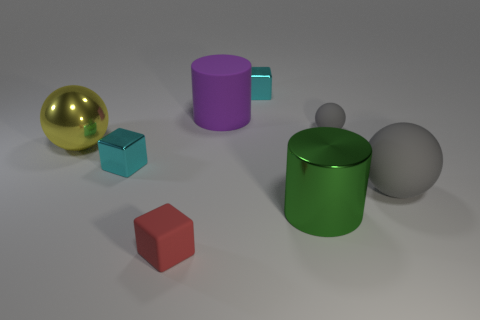Subtract all yellow balls. How many balls are left? 2 Subtract all tiny gray spheres. How many spheres are left? 2 Subtract 0 red balls. How many objects are left? 8 Subtract all cubes. How many objects are left? 5 Subtract 1 cubes. How many cubes are left? 2 Subtract all cyan cylinders. Subtract all gray cubes. How many cylinders are left? 2 Subtract all gray spheres. How many red blocks are left? 1 Subtract all red matte objects. Subtract all small rubber cubes. How many objects are left? 6 Add 6 small rubber objects. How many small rubber objects are left? 8 Add 5 red shiny cylinders. How many red shiny cylinders exist? 5 